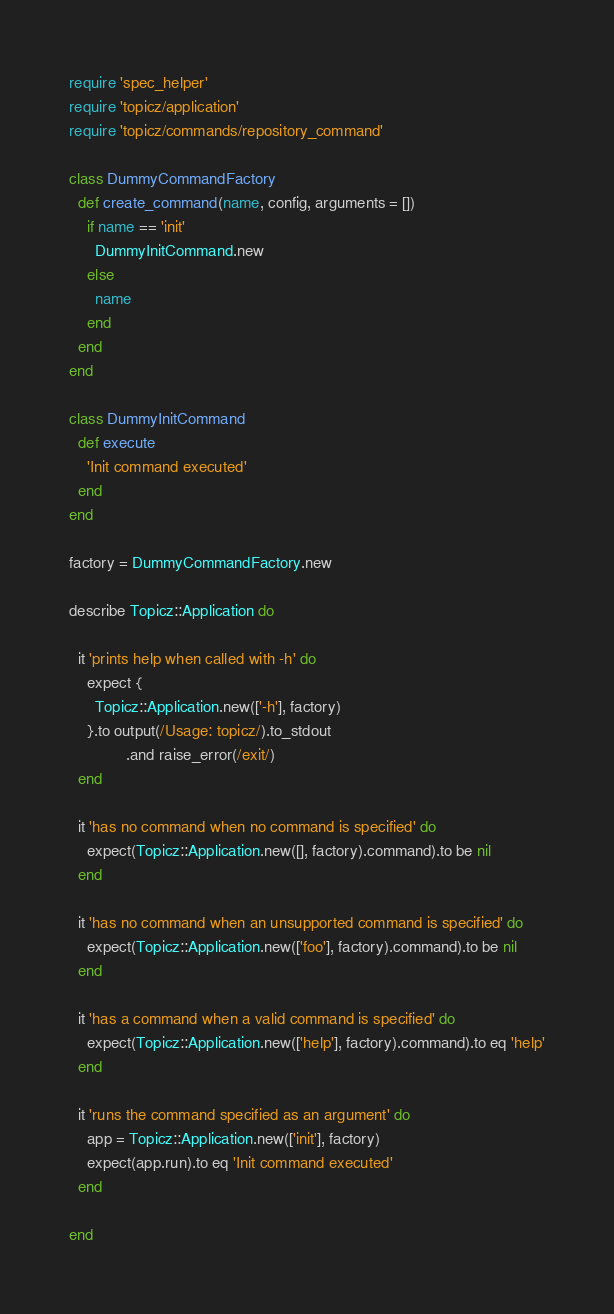<code> <loc_0><loc_0><loc_500><loc_500><_Ruby_>require 'spec_helper'
require 'topicz/application'
require 'topicz/commands/repository_command'

class DummyCommandFactory
  def create_command(name, config, arguments = [])
    if name == 'init'
      DummyInitCommand.new
    else
      name
    end
  end
end

class DummyInitCommand
  def execute
    'Init command executed'
  end
end

factory = DummyCommandFactory.new

describe Topicz::Application do

  it 'prints help when called with -h' do
    expect {
      Topicz::Application.new(['-h'], factory)
    }.to output(/Usage: topicz/).to_stdout
             .and raise_error(/exit/)
  end

  it 'has no command when no command is specified' do
    expect(Topicz::Application.new([], factory).command).to be nil
  end

  it 'has no command when an unsupported command is specified' do
    expect(Topicz::Application.new(['foo'], factory).command).to be nil
  end

  it 'has a command when a valid command is specified' do
    expect(Topicz::Application.new(['help'], factory).command).to eq 'help'
  end

  it 'runs the command specified as an argument' do
    app = Topicz::Application.new(['init'], factory)
    expect(app.run).to eq 'Init command executed'
  end

end
</code> 